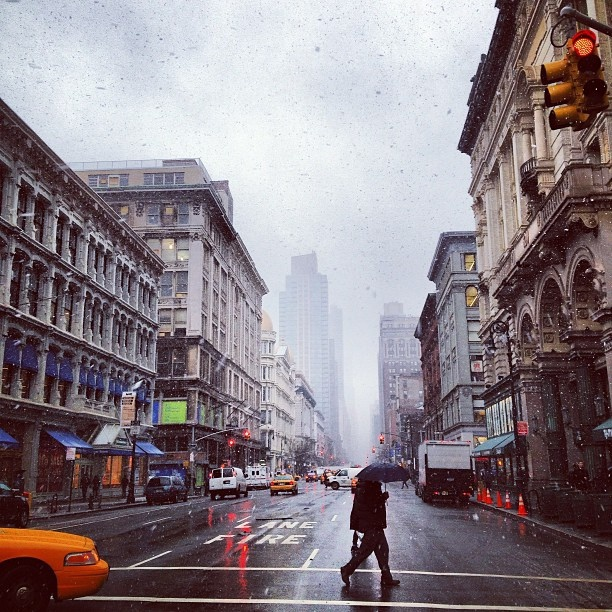Describe the objects in this image and their specific colors. I can see car in darkgray, black, brown, red, and maroon tones, traffic light in darkgray, black, maroon, and brown tones, truck in darkgray, black, gray, and maroon tones, people in darkgray, black, and gray tones, and car in darkgray, black, maroon, and gray tones in this image. 